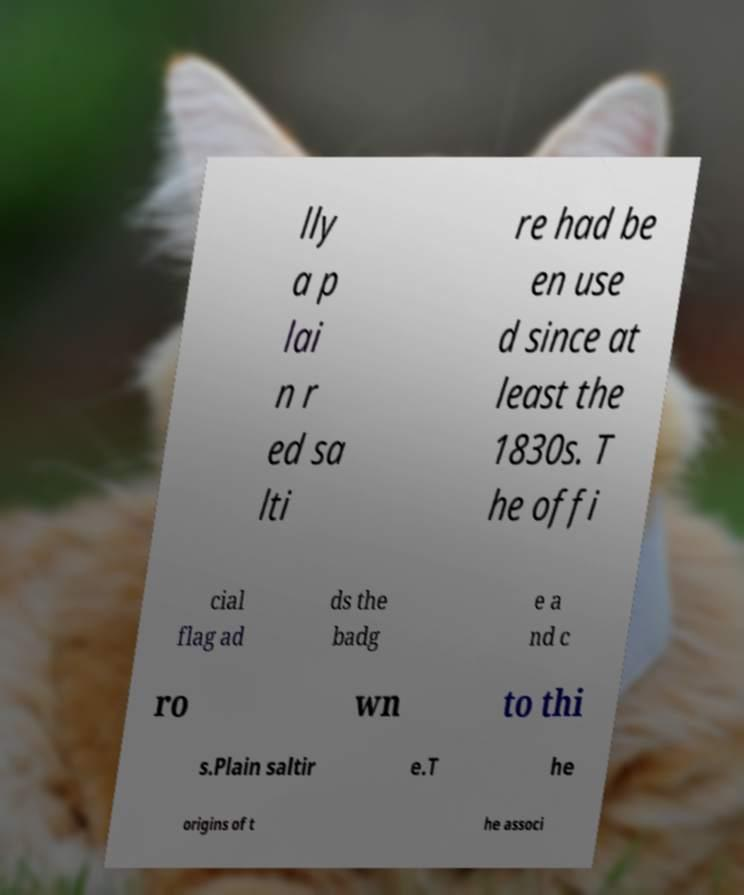For documentation purposes, I need the text within this image transcribed. Could you provide that? lly a p lai n r ed sa lti re had be en use d since at least the 1830s. T he offi cial flag ad ds the badg e a nd c ro wn to thi s.Plain saltir e.T he origins of t he associ 